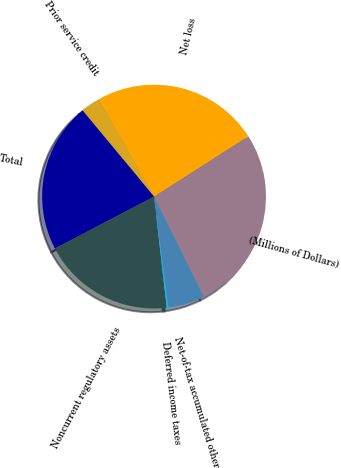Convert chart. <chart><loc_0><loc_0><loc_500><loc_500><pie_chart><fcel>(Millions of Dollars)<fcel>Net loss<fcel>Prior service credit<fcel>Total<fcel>Noncurrent regulatory assets<fcel>Deferred income taxes<fcel>Net-of-tax accumulated other<nl><fcel>26.72%<fcel>24.19%<fcel>2.77%<fcel>21.66%<fcel>19.13%<fcel>0.24%<fcel>5.3%<nl></chart> 